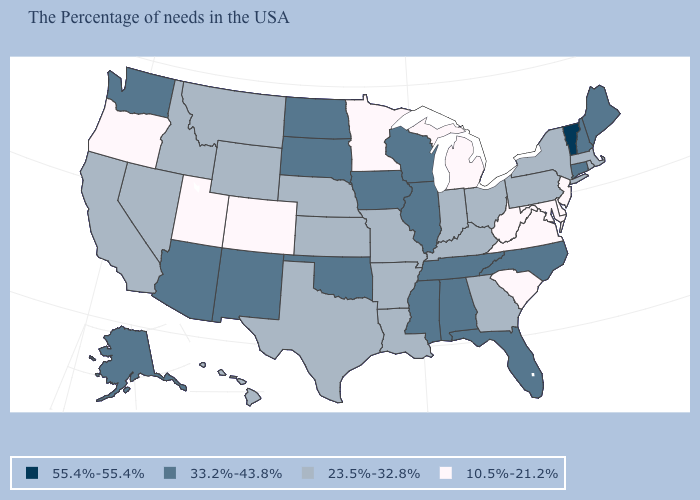Name the states that have a value in the range 23.5%-32.8%?
Be succinct. Massachusetts, Rhode Island, New York, Pennsylvania, Ohio, Georgia, Kentucky, Indiana, Louisiana, Missouri, Arkansas, Kansas, Nebraska, Texas, Wyoming, Montana, Idaho, Nevada, California, Hawaii. What is the value of Vermont?
Quick response, please. 55.4%-55.4%. What is the value of New Mexico?
Give a very brief answer. 33.2%-43.8%. What is the value of Nebraska?
Be succinct. 23.5%-32.8%. What is the lowest value in the USA?
Be succinct. 10.5%-21.2%. Among the states that border Iowa , does Minnesota have the highest value?
Answer briefly. No. Name the states that have a value in the range 33.2%-43.8%?
Keep it brief. Maine, New Hampshire, Connecticut, North Carolina, Florida, Alabama, Tennessee, Wisconsin, Illinois, Mississippi, Iowa, Oklahoma, South Dakota, North Dakota, New Mexico, Arizona, Washington, Alaska. Does New Mexico have a higher value than Wyoming?
Give a very brief answer. Yes. What is the value of South Carolina?
Be succinct. 10.5%-21.2%. Does Illinois have a higher value than Idaho?
Answer briefly. Yes. Which states have the lowest value in the South?
Quick response, please. Delaware, Maryland, Virginia, South Carolina, West Virginia. Which states have the highest value in the USA?
Keep it brief. Vermont. What is the value of Connecticut?
Concise answer only. 33.2%-43.8%. What is the value of Louisiana?
Concise answer only. 23.5%-32.8%. Name the states that have a value in the range 55.4%-55.4%?
Short answer required. Vermont. 